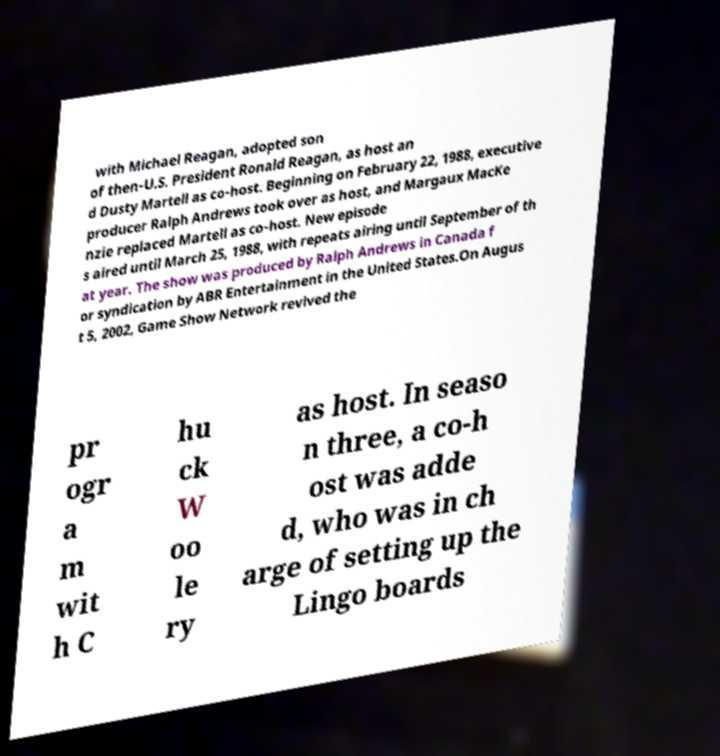Can you read and provide the text displayed in the image?This photo seems to have some interesting text. Can you extract and type it out for me? with Michael Reagan, adopted son of then-U.S. President Ronald Reagan, as host an d Dusty Martell as co-host. Beginning on February 22, 1988, executive producer Ralph Andrews took over as host, and Margaux MacKe nzie replaced Martell as co-host. New episode s aired until March 25, 1988, with repeats airing until September of th at year. The show was produced by Ralph Andrews in Canada f or syndication by ABR Entertainment in the United States.On Augus t 5, 2002, Game Show Network revived the pr ogr a m wit h C hu ck W oo le ry as host. In seaso n three, a co-h ost was adde d, who was in ch arge of setting up the Lingo boards 